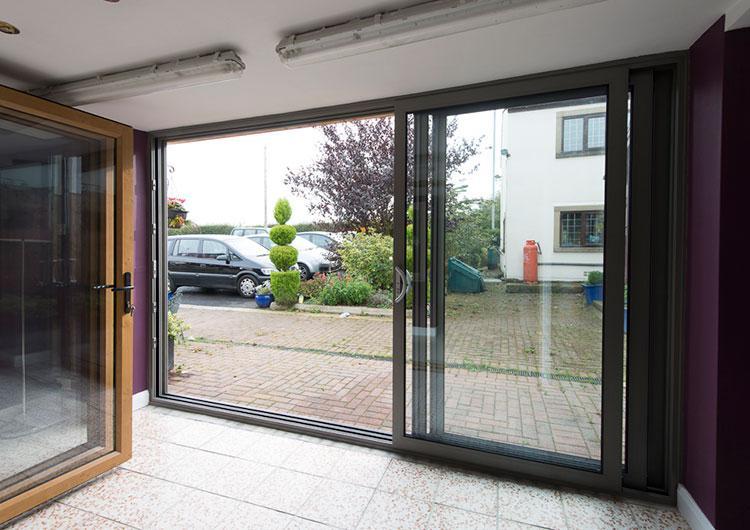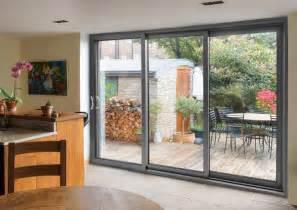The first image is the image on the left, the second image is the image on the right. For the images shown, is this caption "There are three wooden framed glass panel and at least one full set is closed." true? Answer yes or no. No. The first image is the image on the left, the second image is the image on the right. Analyze the images presented: Is the assertion "The doors in the right image are open." valid? Answer yes or no. No. 